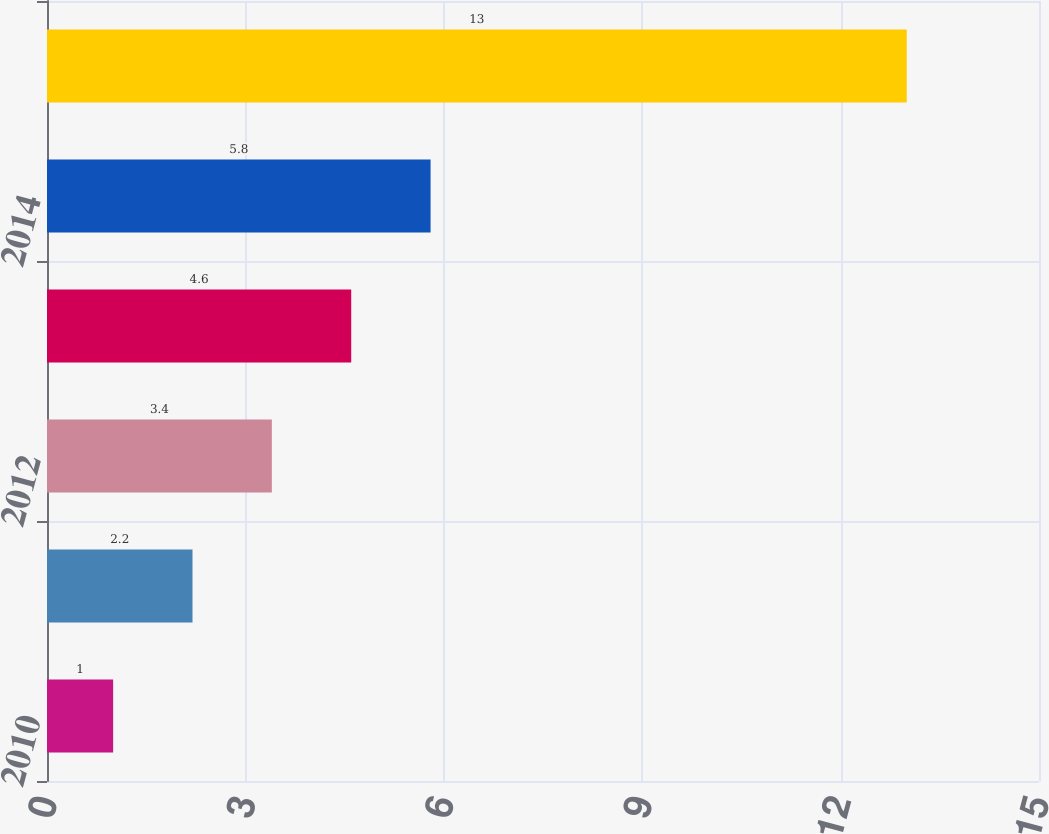<chart> <loc_0><loc_0><loc_500><loc_500><bar_chart><fcel>2010<fcel>2011<fcel>2012<fcel>2013<fcel>2014<fcel>2015 - 2019<nl><fcel>1<fcel>2.2<fcel>3.4<fcel>4.6<fcel>5.8<fcel>13<nl></chart> 